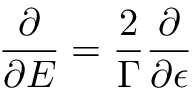<formula> <loc_0><loc_0><loc_500><loc_500>\frac { \partial } { \partial E } = \frac { 2 } { \Gamma } \frac { \partial } { \partial \epsilon }</formula> 